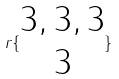<formula> <loc_0><loc_0><loc_500><loc_500>r \{ \begin{matrix} 3 , 3 , 3 \\ 3 \end{matrix} \}</formula> 